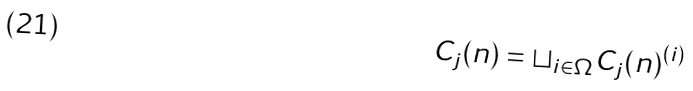Convert formula to latex. <formula><loc_0><loc_0><loc_500><loc_500>C _ { j } ( n ) = \sqcup _ { i \in \Omega } C _ { j } ( n ) ^ { ( i ) }</formula> 